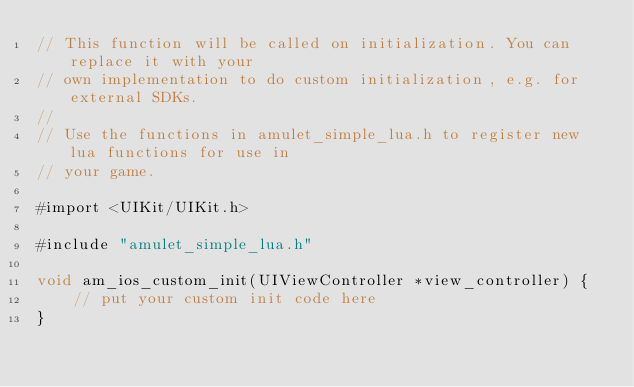Convert code to text. <code><loc_0><loc_0><loc_500><loc_500><_ObjectiveC_>// This function will be called on initialization. You can replace it with your
// own implementation to do custom initialization, e.g. for external SDKs.
// 
// Use the functions in amulet_simple_lua.h to register new lua functions for use in
// your game.

#import <UIKit/UIKit.h>

#include "amulet_simple_lua.h"

void am_ios_custom_init(UIViewController *view_controller) {
    // put your custom init code here
}
</code> 